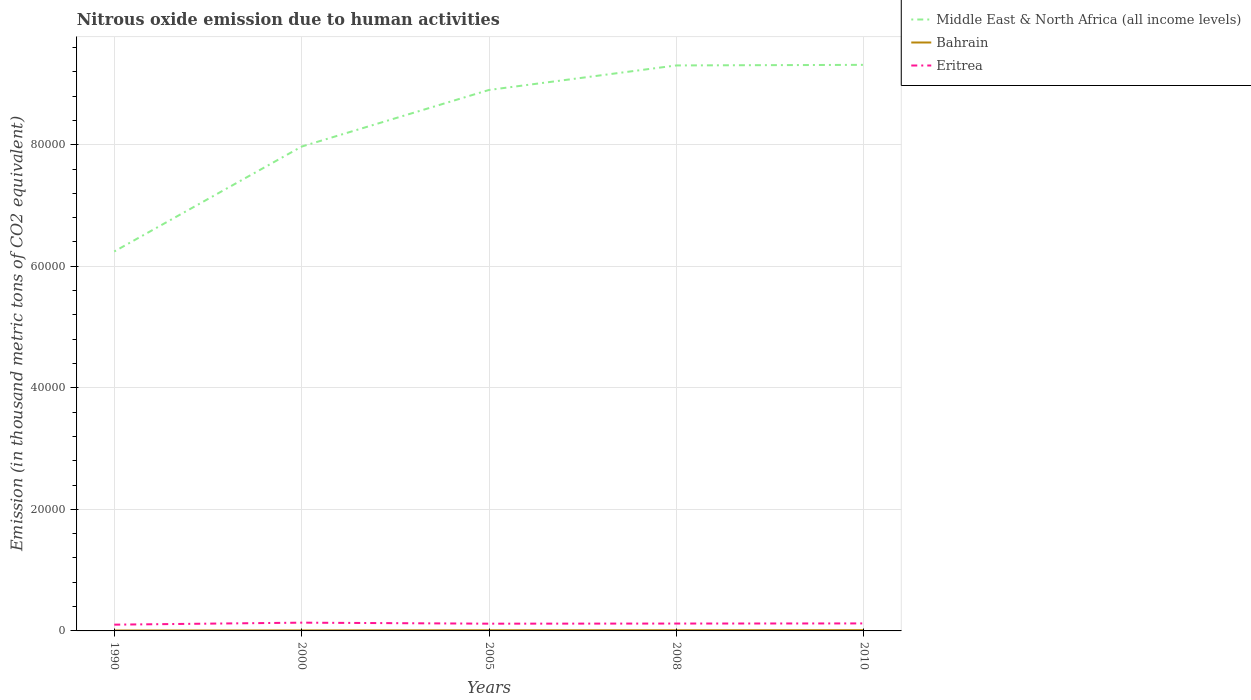Is the number of lines equal to the number of legend labels?
Make the answer very short. Yes. Across all years, what is the maximum amount of nitrous oxide emitted in Middle East & North Africa (all income levels)?
Your answer should be very brief. 6.24e+04. What is the total amount of nitrous oxide emitted in Eritrea in the graph?
Provide a short and direct response. -42.3. What is the difference between the highest and the second highest amount of nitrous oxide emitted in Eritrea?
Make the answer very short. 329.7. Is the amount of nitrous oxide emitted in Middle East & North Africa (all income levels) strictly greater than the amount of nitrous oxide emitted in Eritrea over the years?
Provide a succinct answer. No. How many years are there in the graph?
Offer a very short reply. 5. Does the graph contain any zero values?
Keep it short and to the point. No. Does the graph contain grids?
Ensure brevity in your answer.  Yes. Where does the legend appear in the graph?
Make the answer very short. Top right. How many legend labels are there?
Your answer should be compact. 3. How are the legend labels stacked?
Your response must be concise. Vertical. What is the title of the graph?
Offer a terse response. Nitrous oxide emission due to human activities. What is the label or title of the X-axis?
Your answer should be very brief. Years. What is the label or title of the Y-axis?
Offer a very short reply. Emission (in thousand metric tons of CO2 equivalent). What is the Emission (in thousand metric tons of CO2 equivalent) in Middle East & North Africa (all income levels) in 1990?
Give a very brief answer. 6.24e+04. What is the Emission (in thousand metric tons of CO2 equivalent) of Bahrain in 1990?
Ensure brevity in your answer.  70.2. What is the Emission (in thousand metric tons of CO2 equivalent) of Eritrea in 1990?
Ensure brevity in your answer.  1030.6. What is the Emission (in thousand metric tons of CO2 equivalent) of Middle East & North Africa (all income levels) in 2000?
Make the answer very short. 7.97e+04. What is the Emission (in thousand metric tons of CO2 equivalent) in Bahrain in 2000?
Ensure brevity in your answer.  88.2. What is the Emission (in thousand metric tons of CO2 equivalent) in Eritrea in 2000?
Your answer should be very brief. 1360.3. What is the Emission (in thousand metric tons of CO2 equivalent) of Middle East & North Africa (all income levels) in 2005?
Your answer should be very brief. 8.90e+04. What is the Emission (in thousand metric tons of CO2 equivalent) of Bahrain in 2005?
Provide a succinct answer. 112.9. What is the Emission (in thousand metric tons of CO2 equivalent) in Eritrea in 2005?
Give a very brief answer. 1191.7. What is the Emission (in thousand metric tons of CO2 equivalent) in Middle East & North Africa (all income levels) in 2008?
Keep it short and to the point. 9.30e+04. What is the Emission (in thousand metric tons of CO2 equivalent) in Bahrain in 2008?
Give a very brief answer. 116.7. What is the Emission (in thousand metric tons of CO2 equivalent) of Eritrea in 2008?
Make the answer very short. 1212.8. What is the Emission (in thousand metric tons of CO2 equivalent) in Middle East & North Africa (all income levels) in 2010?
Offer a very short reply. 9.31e+04. What is the Emission (in thousand metric tons of CO2 equivalent) in Bahrain in 2010?
Provide a short and direct response. 128.6. What is the Emission (in thousand metric tons of CO2 equivalent) in Eritrea in 2010?
Ensure brevity in your answer.  1234. Across all years, what is the maximum Emission (in thousand metric tons of CO2 equivalent) in Middle East & North Africa (all income levels)?
Ensure brevity in your answer.  9.31e+04. Across all years, what is the maximum Emission (in thousand metric tons of CO2 equivalent) in Bahrain?
Ensure brevity in your answer.  128.6. Across all years, what is the maximum Emission (in thousand metric tons of CO2 equivalent) in Eritrea?
Give a very brief answer. 1360.3. Across all years, what is the minimum Emission (in thousand metric tons of CO2 equivalent) of Middle East & North Africa (all income levels)?
Your response must be concise. 6.24e+04. Across all years, what is the minimum Emission (in thousand metric tons of CO2 equivalent) in Bahrain?
Provide a succinct answer. 70.2. Across all years, what is the minimum Emission (in thousand metric tons of CO2 equivalent) in Eritrea?
Your response must be concise. 1030.6. What is the total Emission (in thousand metric tons of CO2 equivalent) of Middle East & North Africa (all income levels) in the graph?
Your answer should be compact. 4.17e+05. What is the total Emission (in thousand metric tons of CO2 equivalent) in Bahrain in the graph?
Your response must be concise. 516.6. What is the total Emission (in thousand metric tons of CO2 equivalent) in Eritrea in the graph?
Ensure brevity in your answer.  6029.4. What is the difference between the Emission (in thousand metric tons of CO2 equivalent) in Middle East & North Africa (all income levels) in 1990 and that in 2000?
Make the answer very short. -1.73e+04. What is the difference between the Emission (in thousand metric tons of CO2 equivalent) of Eritrea in 1990 and that in 2000?
Make the answer very short. -329.7. What is the difference between the Emission (in thousand metric tons of CO2 equivalent) of Middle East & North Africa (all income levels) in 1990 and that in 2005?
Offer a very short reply. -2.66e+04. What is the difference between the Emission (in thousand metric tons of CO2 equivalent) in Bahrain in 1990 and that in 2005?
Provide a short and direct response. -42.7. What is the difference between the Emission (in thousand metric tons of CO2 equivalent) of Eritrea in 1990 and that in 2005?
Your response must be concise. -161.1. What is the difference between the Emission (in thousand metric tons of CO2 equivalent) of Middle East & North Africa (all income levels) in 1990 and that in 2008?
Make the answer very short. -3.06e+04. What is the difference between the Emission (in thousand metric tons of CO2 equivalent) in Bahrain in 1990 and that in 2008?
Make the answer very short. -46.5. What is the difference between the Emission (in thousand metric tons of CO2 equivalent) of Eritrea in 1990 and that in 2008?
Provide a succinct answer. -182.2. What is the difference between the Emission (in thousand metric tons of CO2 equivalent) in Middle East & North Africa (all income levels) in 1990 and that in 2010?
Make the answer very short. -3.07e+04. What is the difference between the Emission (in thousand metric tons of CO2 equivalent) of Bahrain in 1990 and that in 2010?
Offer a very short reply. -58.4. What is the difference between the Emission (in thousand metric tons of CO2 equivalent) in Eritrea in 1990 and that in 2010?
Offer a terse response. -203.4. What is the difference between the Emission (in thousand metric tons of CO2 equivalent) of Middle East & North Africa (all income levels) in 2000 and that in 2005?
Make the answer very short. -9317.5. What is the difference between the Emission (in thousand metric tons of CO2 equivalent) in Bahrain in 2000 and that in 2005?
Offer a very short reply. -24.7. What is the difference between the Emission (in thousand metric tons of CO2 equivalent) in Eritrea in 2000 and that in 2005?
Offer a very short reply. 168.6. What is the difference between the Emission (in thousand metric tons of CO2 equivalent) of Middle East & North Africa (all income levels) in 2000 and that in 2008?
Your response must be concise. -1.34e+04. What is the difference between the Emission (in thousand metric tons of CO2 equivalent) of Bahrain in 2000 and that in 2008?
Your answer should be very brief. -28.5. What is the difference between the Emission (in thousand metric tons of CO2 equivalent) of Eritrea in 2000 and that in 2008?
Give a very brief answer. 147.5. What is the difference between the Emission (in thousand metric tons of CO2 equivalent) in Middle East & North Africa (all income levels) in 2000 and that in 2010?
Keep it short and to the point. -1.34e+04. What is the difference between the Emission (in thousand metric tons of CO2 equivalent) of Bahrain in 2000 and that in 2010?
Ensure brevity in your answer.  -40.4. What is the difference between the Emission (in thousand metric tons of CO2 equivalent) in Eritrea in 2000 and that in 2010?
Your answer should be compact. 126.3. What is the difference between the Emission (in thousand metric tons of CO2 equivalent) of Middle East & North Africa (all income levels) in 2005 and that in 2008?
Ensure brevity in your answer.  -4035.3. What is the difference between the Emission (in thousand metric tons of CO2 equivalent) of Bahrain in 2005 and that in 2008?
Keep it short and to the point. -3.8. What is the difference between the Emission (in thousand metric tons of CO2 equivalent) of Eritrea in 2005 and that in 2008?
Offer a very short reply. -21.1. What is the difference between the Emission (in thousand metric tons of CO2 equivalent) of Middle East & North Africa (all income levels) in 2005 and that in 2010?
Offer a very short reply. -4129.8. What is the difference between the Emission (in thousand metric tons of CO2 equivalent) in Bahrain in 2005 and that in 2010?
Provide a succinct answer. -15.7. What is the difference between the Emission (in thousand metric tons of CO2 equivalent) in Eritrea in 2005 and that in 2010?
Offer a very short reply. -42.3. What is the difference between the Emission (in thousand metric tons of CO2 equivalent) of Middle East & North Africa (all income levels) in 2008 and that in 2010?
Provide a short and direct response. -94.5. What is the difference between the Emission (in thousand metric tons of CO2 equivalent) in Bahrain in 2008 and that in 2010?
Provide a succinct answer. -11.9. What is the difference between the Emission (in thousand metric tons of CO2 equivalent) in Eritrea in 2008 and that in 2010?
Your response must be concise. -21.2. What is the difference between the Emission (in thousand metric tons of CO2 equivalent) of Middle East & North Africa (all income levels) in 1990 and the Emission (in thousand metric tons of CO2 equivalent) of Bahrain in 2000?
Your answer should be compact. 6.23e+04. What is the difference between the Emission (in thousand metric tons of CO2 equivalent) in Middle East & North Africa (all income levels) in 1990 and the Emission (in thousand metric tons of CO2 equivalent) in Eritrea in 2000?
Offer a terse response. 6.11e+04. What is the difference between the Emission (in thousand metric tons of CO2 equivalent) in Bahrain in 1990 and the Emission (in thousand metric tons of CO2 equivalent) in Eritrea in 2000?
Your answer should be very brief. -1290.1. What is the difference between the Emission (in thousand metric tons of CO2 equivalent) in Middle East & North Africa (all income levels) in 1990 and the Emission (in thousand metric tons of CO2 equivalent) in Bahrain in 2005?
Offer a terse response. 6.23e+04. What is the difference between the Emission (in thousand metric tons of CO2 equivalent) in Middle East & North Africa (all income levels) in 1990 and the Emission (in thousand metric tons of CO2 equivalent) in Eritrea in 2005?
Ensure brevity in your answer.  6.12e+04. What is the difference between the Emission (in thousand metric tons of CO2 equivalent) in Bahrain in 1990 and the Emission (in thousand metric tons of CO2 equivalent) in Eritrea in 2005?
Your answer should be compact. -1121.5. What is the difference between the Emission (in thousand metric tons of CO2 equivalent) in Middle East & North Africa (all income levels) in 1990 and the Emission (in thousand metric tons of CO2 equivalent) in Bahrain in 2008?
Your response must be concise. 6.23e+04. What is the difference between the Emission (in thousand metric tons of CO2 equivalent) of Middle East & North Africa (all income levels) in 1990 and the Emission (in thousand metric tons of CO2 equivalent) of Eritrea in 2008?
Give a very brief answer. 6.12e+04. What is the difference between the Emission (in thousand metric tons of CO2 equivalent) of Bahrain in 1990 and the Emission (in thousand metric tons of CO2 equivalent) of Eritrea in 2008?
Your answer should be compact. -1142.6. What is the difference between the Emission (in thousand metric tons of CO2 equivalent) in Middle East & North Africa (all income levels) in 1990 and the Emission (in thousand metric tons of CO2 equivalent) in Bahrain in 2010?
Your answer should be very brief. 6.23e+04. What is the difference between the Emission (in thousand metric tons of CO2 equivalent) in Middle East & North Africa (all income levels) in 1990 and the Emission (in thousand metric tons of CO2 equivalent) in Eritrea in 2010?
Provide a succinct answer. 6.12e+04. What is the difference between the Emission (in thousand metric tons of CO2 equivalent) in Bahrain in 1990 and the Emission (in thousand metric tons of CO2 equivalent) in Eritrea in 2010?
Your response must be concise. -1163.8. What is the difference between the Emission (in thousand metric tons of CO2 equivalent) of Middle East & North Africa (all income levels) in 2000 and the Emission (in thousand metric tons of CO2 equivalent) of Bahrain in 2005?
Offer a terse response. 7.96e+04. What is the difference between the Emission (in thousand metric tons of CO2 equivalent) of Middle East & North Africa (all income levels) in 2000 and the Emission (in thousand metric tons of CO2 equivalent) of Eritrea in 2005?
Offer a terse response. 7.85e+04. What is the difference between the Emission (in thousand metric tons of CO2 equivalent) in Bahrain in 2000 and the Emission (in thousand metric tons of CO2 equivalent) in Eritrea in 2005?
Your answer should be very brief. -1103.5. What is the difference between the Emission (in thousand metric tons of CO2 equivalent) of Middle East & North Africa (all income levels) in 2000 and the Emission (in thousand metric tons of CO2 equivalent) of Bahrain in 2008?
Your answer should be compact. 7.96e+04. What is the difference between the Emission (in thousand metric tons of CO2 equivalent) in Middle East & North Africa (all income levels) in 2000 and the Emission (in thousand metric tons of CO2 equivalent) in Eritrea in 2008?
Your answer should be compact. 7.85e+04. What is the difference between the Emission (in thousand metric tons of CO2 equivalent) of Bahrain in 2000 and the Emission (in thousand metric tons of CO2 equivalent) of Eritrea in 2008?
Your answer should be compact. -1124.6. What is the difference between the Emission (in thousand metric tons of CO2 equivalent) of Middle East & North Africa (all income levels) in 2000 and the Emission (in thousand metric tons of CO2 equivalent) of Bahrain in 2010?
Give a very brief answer. 7.96e+04. What is the difference between the Emission (in thousand metric tons of CO2 equivalent) of Middle East & North Africa (all income levels) in 2000 and the Emission (in thousand metric tons of CO2 equivalent) of Eritrea in 2010?
Your answer should be compact. 7.85e+04. What is the difference between the Emission (in thousand metric tons of CO2 equivalent) in Bahrain in 2000 and the Emission (in thousand metric tons of CO2 equivalent) in Eritrea in 2010?
Give a very brief answer. -1145.8. What is the difference between the Emission (in thousand metric tons of CO2 equivalent) of Middle East & North Africa (all income levels) in 2005 and the Emission (in thousand metric tons of CO2 equivalent) of Bahrain in 2008?
Make the answer very short. 8.89e+04. What is the difference between the Emission (in thousand metric tons of CO2 equivalent) of Middle East & North Africa (all income levels) in 2005 and the Emission (in thousand metric tons of CO2 equivalent) of Eritrea in 2008?
Ensure brevity in your answer.  8.78e+04. What is the difference between the Emission (in thousand metric tons of CO2 equivalent) in Bahrain in 2005 and the Emission (in thousand metric tons of CO2 equivalent) in Eritrea in 2008?
Make the answer very short. -1099.9. What is the difference between the Emission (in thousand metric tons of CO2 equivalent) in Middle East & North Africa (all income levels) in 2005 and the Emission (in thousand metric tons of CO2 equivalent) in Bahrain in 2010?
Provide a short and direct response. 8.89e+04. What is the difference between the Emission (in thousand metric tons of CO2 equivalent) in Middle East & North Africa (all income levels) in 2005 and the Emission (in thousand metric tons of CO2 equivalent) in Eritrea in 2010?
Offer a very short reply. 8.78e+04. What is the difference between the Emission (in thousand metric tons of CO2 equivalent) in Bahrain in 2005 and the Emission (in thousand metric tons of CO2 equivalent) in Eritrea in 2010?
Give a very brief answer. -1121.1. What is the difference between the Emission (in thousand metric tons of CO2 equivalent) of Middle East & North Africa (all income levels) in 2008 and the Emission (in thousand metric tons of CO2 equivalent) of Bahrain in 2010?
Give a very brief answer. 9.29e+04. What is the difference between the Emission (in thousand metric tons of CO2 equivalent) in Middle East & North Africa (all income levels) in 2008 and the Emission (in thousand metric tons of CO2 equivalent) in Eritrea in 2010?
Your response must be concise. 9.18e+04. What is the difference between the Emission (in thousand metric tons of CO2 equivalent) of Bahrain in 2008 and the Emission (in thousand metric tons of CO2 equivalent) of Eritrea in 2010?
Your answer should be very brief. -1117.3. What is the average Emission (in thousand metric tons of CO2 equivalent) of Middle East & North Africa (all income levels) per year?
Provide a short and direct response. 8.35e+04. What is the average Emission (in thousand metric tons of CO2 equivalent) of Bahrain per year?
Ensure brevity in your answer.  103.32. What is the average Emission (in thousand metric tons of CO2 equivalent) of Eritrea per year?
Make the answer very short. 1205.88. In the year 1990, what is the difference between the Emission (in thousand metric tons of CO2 equivalent) in Middle East & North Africa (all income levels) and Emission (in thousand metric tons of CO2 equivalent) in Bahrain?
Make the answer very short. 6.24e+04. In the year 1990, what is the difference between the Emission (in thousand metric tons of CO2 equivalent) of Middle East & North Africa (all income levels) and Emission (in thousand metric tons of CO2 equivalent) of Eritrea?
Make the answer very short. 6.14e+04. In the year 1990, what is the difference between the Emission (in thousand metric tons of CO2 equivalent) in Bahrain and Emission (in thousand metric tons of CO2 equivalent) in Eritrea?
Your answer should be very brief. -960.4. In the year 2000, what is the difference between the Emission (in thousand metric tons of CO2 equivalent) in Middle East & North Africa (all income levels) and Emission (in thousand metric tons of CO2 equivalent) in Bahrain?
Provide a short and direct response. 7.96e+04. In the year 2000, what is the difference between the Emission (in thousand metric tons of CO2 equivalent) in Middle East & North Africa (all income levels) and Emission (in thousand metric tons of CO2 equivalent) in Eritrea?
Offer a very short reply. 7.83e+04. In the year 2000, what is the difference between the Emission (in thousand metric tons of CO2 equivalent) in Bahrain and Emission (in thousand metric tons of CO2 equivalent) in Eritrea?
Your response must be concise. -1272.1. In the year 2005, what is the difference between the Emission (in thousand metric tons of CO2 equivalent) in Middle East & North Africa (all income levels) and Emission (in thousand metric tons of CO2 equivalent) in Bahrain?
Make the answer very short. 8.89e+04. In the year 2005, what is the difference between the Emission (in thousand metric tons of CO2 equivalent) of Middle East & North Africa (all income levels) and Emission (in thousand metric tons of CO2 equivalent) of Eritrea?
Offer a terse response. 8.78e+04. In the year 2005, what is the difference between the Emission (in thousand metric tons of CO2 equivalent) in Bahrain and Emission (in thousand metric tons of CO2 equivalent) in Eritrea?
Offer a very short reply. -1078.8. In the year 2008, what is the difference between the Emission (in thousand metric tons of CO2 equivalent) of Middle East & North Africa (all income levels) and Emission (in thousand metric tons of CO2 equivalent) of Bahrain?
Give a very brief answer. 9.29e+04. In the year 2008, what is the difference between the Emission (in thousand metric tons of CO2 equivalent) in Middle East & North Africa (all income levels) and Emission (in thousand metric tons of CO2 equivalent) in Eritrea?
Offer a very short reply. 9.18e+04. In the year 2008, what is the difference between the Emission (in thousand metric tons of CO2 equivalent) in Bahrain and Emission (in thousand metric tons of CO2 equivalent) in Eritrea?
Keep it short and to the point. -1096.1. In the year 2010, what is the difference between the Emission (in thousand metric tons of CO2 equivalent) in Middle East & North Africa (all income levels) and Emission (in thousand metric tons of CO2 equivalent) in Bahrain?
Keep it short and to the point. 9.30e+04. In the year 2010, what is the difference between the Emission (in thousand metric tons of CO2 equivalent) of Middle East & North Africa (all income levels) and Emission (in thousand metric tons of CO2 equivalent) of Eritrea?
Offer a terse response. 9.19e+04. In the year 2010, what is the difference between the Emission (in thousand metric tons of CO2 equivalent) of Bahrain and Emission (in thousand metric tons of CO2 equivalent) of Eritrea?
Give a very brief answer. -1105.4. What is the ratio of the Emission (in thousand metric tons of CO2 equivalent) of Middle East & North Africa (all income levels) in 1990 to that in 2000?
Offer a very short reply. 0.78. What is the ratio of the Emission (in thousand metric tons of CO2 equivalent) of Bahrain in 1990 to that in 2000?
Your response must be concise. 0.8. What is the ratio of the Emission (in thousand metric tons of CO2 equivalent) in Eritrea in 1990 to that in 2000?
Your response must be concise. 0.76. What is the ratio of the Emission (in thousand metric tons of CO2 equivalent) of Middle East & North Africa (all income levels) in 1990 to that in 2005?
Provide a succinct answer. 0.7. What is the ratio of the Emission (in thousand metric tons of CO2 equivalent) in Bahrain in 1990 to that in 2005?
Provide a short and direct response. 0.62. What is the ratio of the Emission (in thousand metric tons of CO2 equivalent) in Eritrea in 1990 to that in 2005?
Offer a very short reply. 0.86. What is the ratio of the Emission (in thousand metric tons of CO2 equivalent) of Middle East & North Africa (all income levels) in 1990 to that in 2008?
Offer a terse response. 0.67. What is the ratio of the Emission (in thousand metric tons of CO2 equivalent) in Bahrain in 1990 to that in 2008?
Make the answer very short. 0.6. What is the ratio of the Emission (in thousand metric tons of CO2 equivalent) of Eritrea in 1990 to that in 2008?
Your answer should be very brief. 0.85. What is the ratio of the Emission (in thousand metric tons of CO2 equivalent) in Middle East & North Africa (all income levels) in 1990 to that in 2010?
Keep it short and to the point. 0.67. What is the ratio of the Emission (in thousand metric tons of CO2 equivalent) in Bahrain in 1990 to that in 2010?
Keep it short and to the point. 0.55. What is the ratio of the Emission (in thousand metric tons of CO2 equivalent) of Eritrea in 1990 to that in 2010?
Keep it short and to the point. 0.84. What is the ratio of the Emission (in thousand metric tons of CO2 equivalent) in Middle East & North Africa (all income levels) in 2000 to that in 2005?
Your answer should be very brief. 0.9. What is the ratio of the Emission (in thousand metric tons of CO2 equivalent) of Bahrain in 2000 to that in 2005?
Offer a very short reply. 0.78. What is the ratio of the Emission (in thousand metric tons of CO2 equivalent) in Eritrea in 2000 to that in 2005?
Your response must be concise. 1.14. What is the ratio of the Emission (in thousand metric tons of CO2 equivalent) of Middle East & North Africa (all income levels) in 2000 to that in 2008?
Your response must be concise. 0.86. What is the ratio of the Emission (in thousand metric tons of CO2 equivalent) in Bahrain in 2000 to that in 2008?
Keep it short and to the point. 0.76. What is the ratio of the Emission (in thousand metric tons of CO2 equivalent) in Eritrea in 2000 to that in 2008?
Your answer should be compact. 1.12. What is the ratio of the Emission (in thousand metric tons of CO2 equivalent) of Middle East & North Africa (all income levels) in 2000 to that in 2010?
Your answer should be compact. 0.86. What is the ratio of the Emission (in thousand metric tons of CO2 equivalent) of Bahrain in 2000 to that in 2010?
Offer a very short reply. 0.69. What is the ratio of the Emission (in thousand metric tons of CO2 equivalent) of Eritrea in 2000 to that in 2010?
Keep it short and to the point. 1.1. What is the ratio of the Emission (in thousand metric tons of CO2 equivalent) in Middle East & North Africa (all income levels) in 2005 to that in 2008?
Provide a short and direct response. 0.96. What is the ratio of the Emission (in thousand metric tons of CO2 equivalent) of Bahrain in 2005 to that in 2008?
Give a very brief answer. 0.97. What is the ratio of the Emission (in thousand metric tons of CO2 equivalent) of Eritrea in 2005 to that in 2008?
Ensure brevity in your answer.  0.98. What is the ratio of the Emission (in thousand metric tons of CO2 equivalent) of Middle East & North Africa (all income levels) in 2005 to that in 2010?
Your response must be concise. 0.96. What is the ratio of the Emission (in thousand metric tons of CO2 equivalent) in Bahrain in 2005 to that in 2010?
Give a very brief answer. 0.88. What is the ratio of the Emission (in thousand metric tons of CO2 equivalent) of Eritrea in 2005 to that in 2010?
Provide a short and direct response. 0.97. What is the ratio of the Emission (in thousand metric tons of CO2 equivalent) of Bahrain in 2008 to that in 2010?
Provide a succinct answer. 0.91. What is the ratio of the Emission (in thousand metric tons of CO2 equivalent) in Eritrea in 2008 to that in 2010?
Your answer should be very brief. 0.98. What is the difference between the highest and the second highest Emission (in thousand metric tons of CO2 equivalent) of Middle East & North Africa (all income levels)?
Your answer should be compact. 94.5. What is the difference between the highest and the second highest Emission (in thousand metric tons of CO2 equivalent) of Eritrea?
Your answer should be compact. 126.3. What is the difference between the highest and the lowest Emission (in thousand metric tons of CO2 equivalent) of Middle East & North Africa (all income levels)?
Ensure brevity in your answer.  3.07e+04. What is the difference between the highest and the lowest Emission (in thousand metric tons of CO2 equivalent) of Bahrain?
Your response must be concise. 58.4. What is the difference between the highest and the lowest Emission (in thousand metric tons of CO2 equivalent) in Eritrea?
Your answer should be compact. 329.7. 